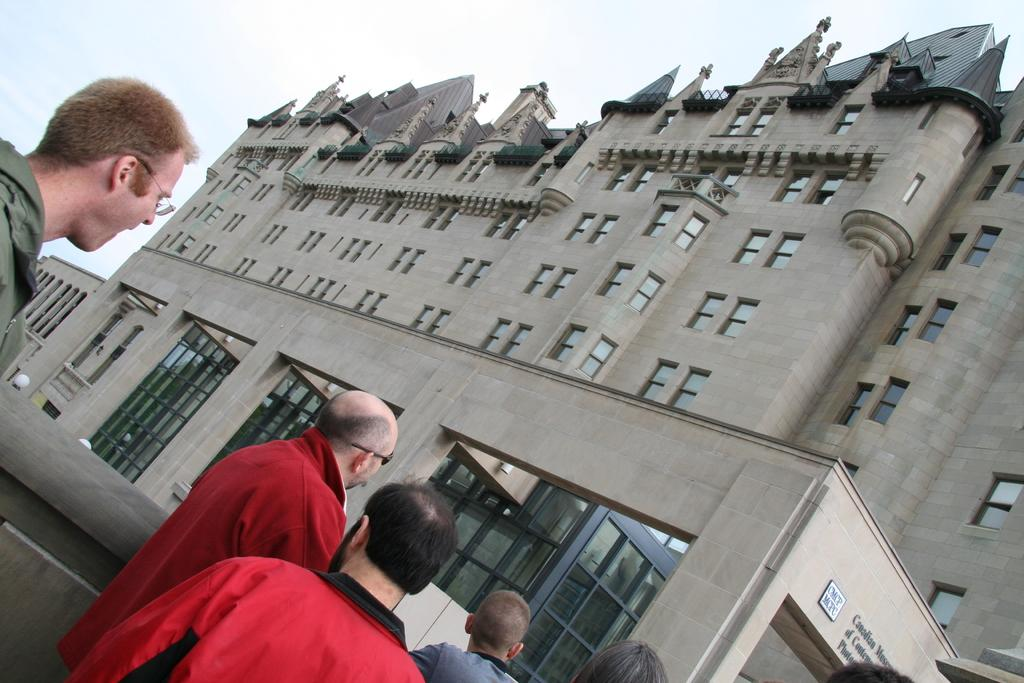What is happening in the image? There is a group of people standing in the image. What can be seen in the background of the image? The sky is visible in the background of the image. Can you describe the building in the image? There is a building with windows in the image. How many turkeys are visible in the image? There are no turkeys present in the image. What type of clouds can be seen in the image? The provided facts do not mention any clouds in the image. 